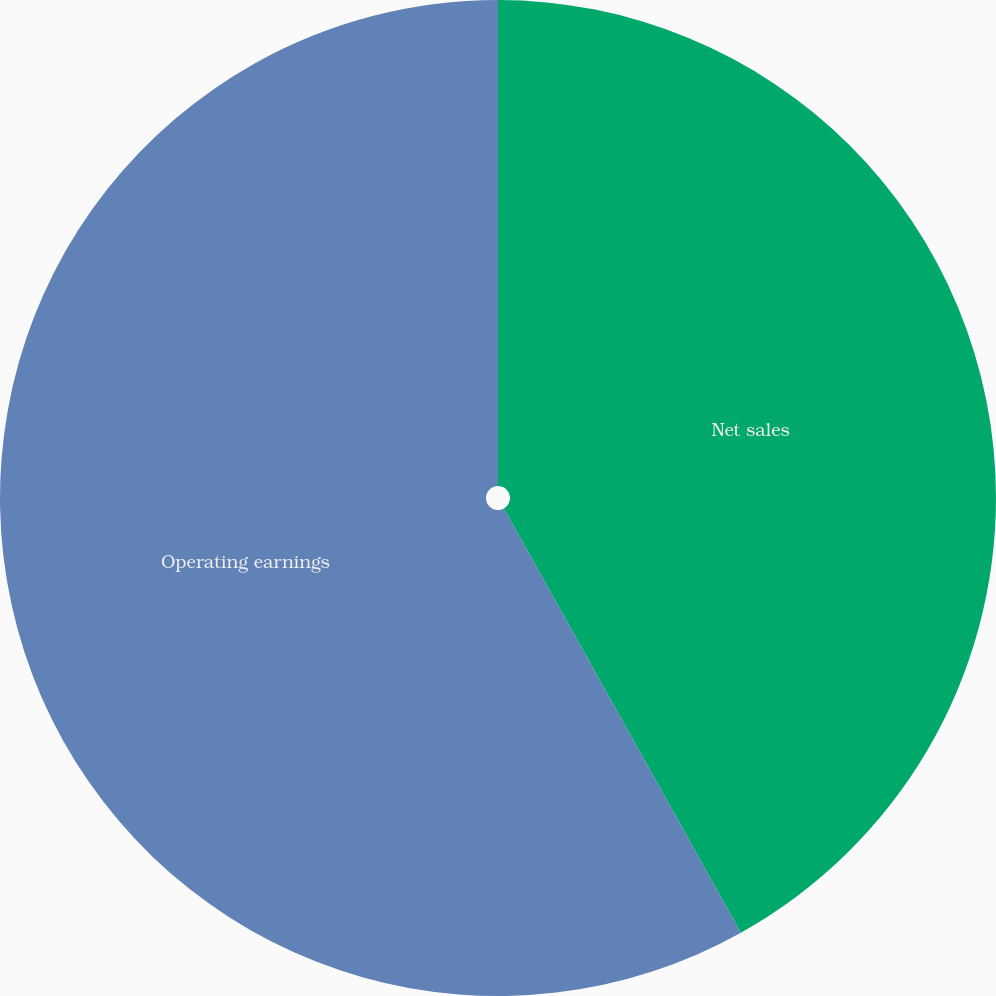Convert chart to OTSL. <chart><loc_0><loc_0><loc_500><loc_500><pie_chart><fcel>Net sales<fcel>Operating earnings<nl><fcel>41.89%<fcel>58.11%<nl></chart> 